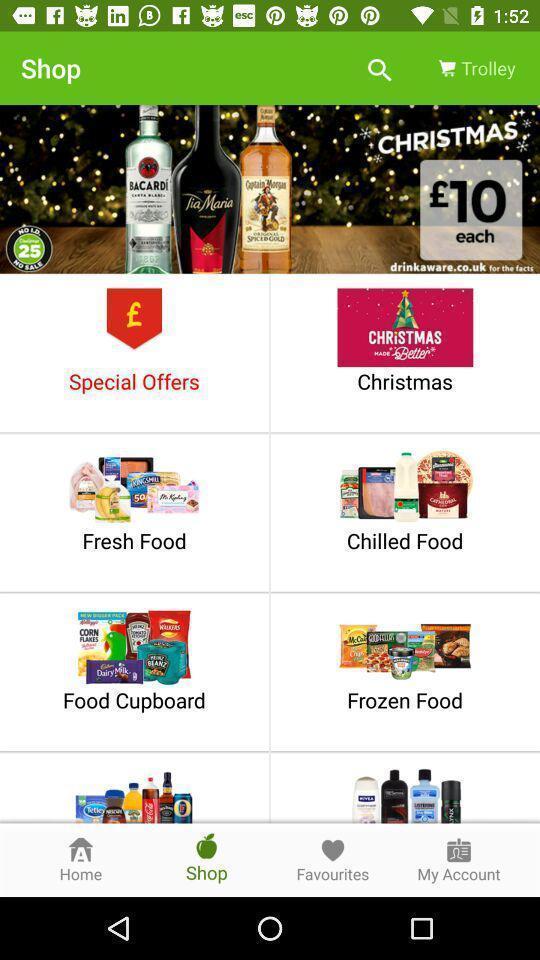Provide a textual representation of this image. Screen showing shop page of a food app. 